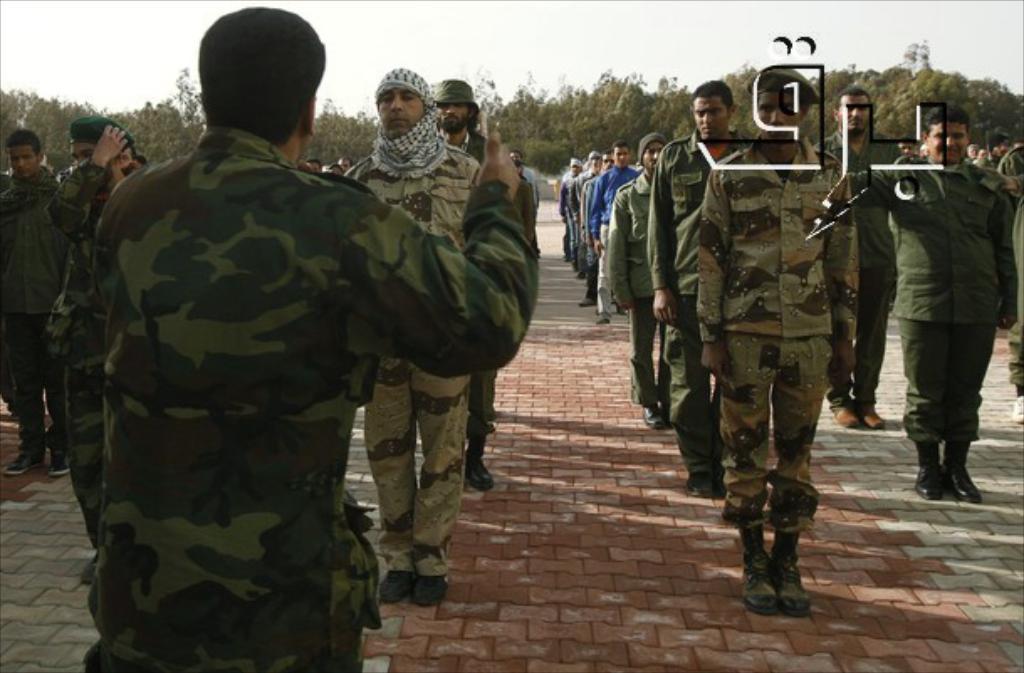Can you describe this image briefly? In this picture we can see a group of people wore shoes and standing on the ground and some of them wore caps and in the background we can see trees, sky. 